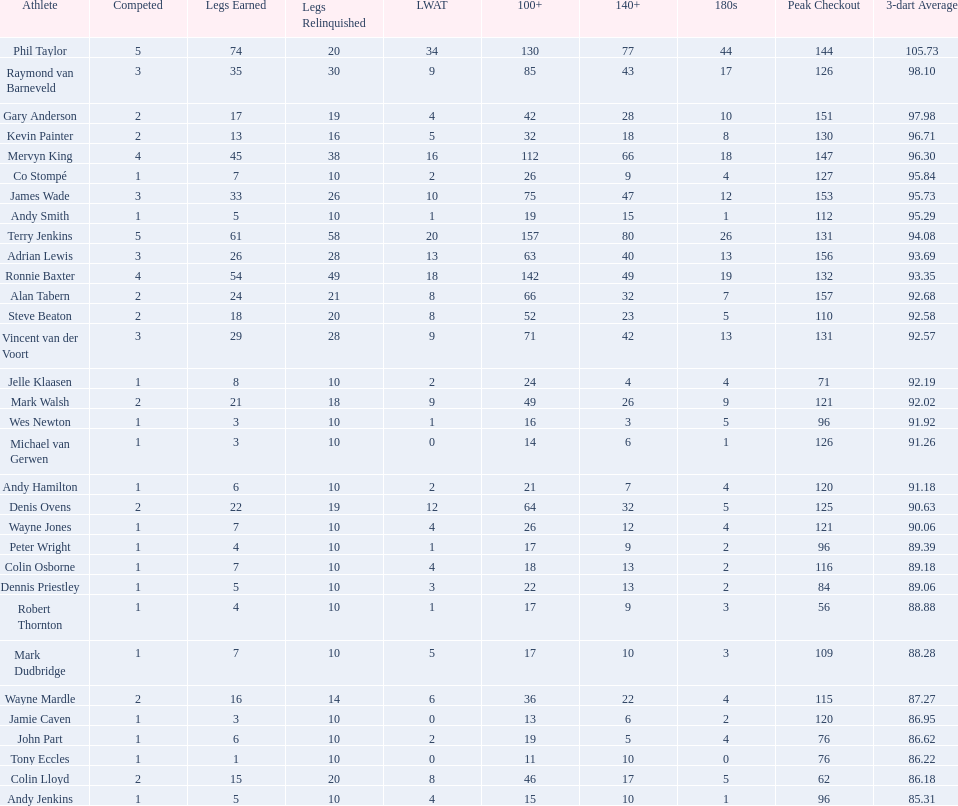What is the total amount of players who played more than 3 games? 4. 